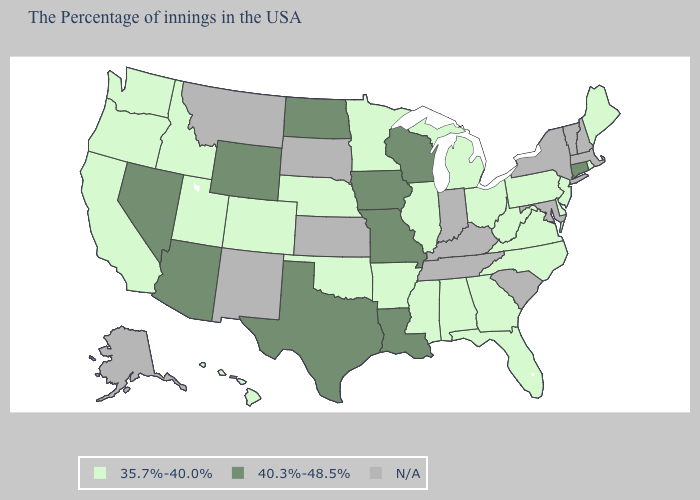Among the states that border Washington , which have the lowest value?
Give a very brief answer. Idaho, Oregon. Does Missouri have the lowest value in the USA?
Give a very brief answer. No. Which states have the lowest value in the MidWest?
Keep it brief. Ohio, Michigan, Illinois, Minnesota, Nebraska. What is the value of Michigan?
Short answer required. 35.7%-40.0%. Does the map have missing data?
Give a very brief answer. Yes. What is the value of South Carolina?
Concise answer only. N/A. Name the states that have a value in the range 35.7%-40.0%?
Give a very brief answer. Maine, Rhode Island, New Jersey, Delaware, Pennsylvania, Virginia, North Carolina, West Virginia, Ohio, Florida, Georgia, Michigan, Alabama, Illinois, Mississippi, Arkansas, Minnesota, Nebraska, Oklahoma, Colorado, Utah, Idaho, California, Washington, Oregon, Hawaii. Does Washington have the highest value in the USA?
Quick response, please. No. Name the states that have a value in the range N/A?
Concise answer only. Massachusetts, New Hampshire, Vermont, New York, Maryland, South Carolina, Kentucky, Indiana, Tennessee, Kansas, South Dakota, New Mexico, Montana, Alaska. Name the states that have a value in the range 35.7%-40.0%?
Concise answer only. Maine, Rhode Island, New Jersey, Delaware, Pennsylvania, Virginia, North Carolina, West Virginia, Ohio, Florida, Georgia, Michigan, Alabama, Illinois, Mississippi, Arkansas, Minnesota, Nebraska, Oklahoma, Colorado, Utah, Idaho, California, Washington, Oregon, Hawaii. Which states hav the highest value in the Northeast?
Give a very brief answer. Connecticut. Which states have the lowest value in the USA?
Keep it brief. Maine, Rhode Island, New Jersey, Delaware, Pennsylvania, Virginia, North Carolina, West Virginia, Ohio, Florida, Georgia, Michigan, Alabama, Illinois, Mississippi, Arkansas, Minnesota, Nebraska, Oklahoma, Colorado, Utah, Idaho, California, Washington, Oregon, Hawaii. What is the value of Alaska?
Be succinct. N/A. 